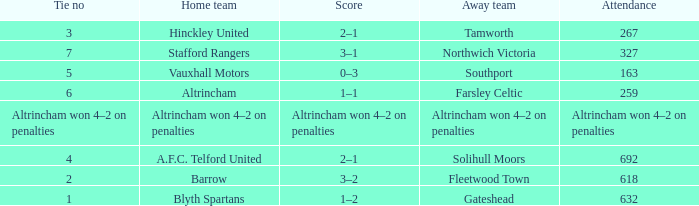What was the attendance for the away team Solihull Moors? 692.0. 